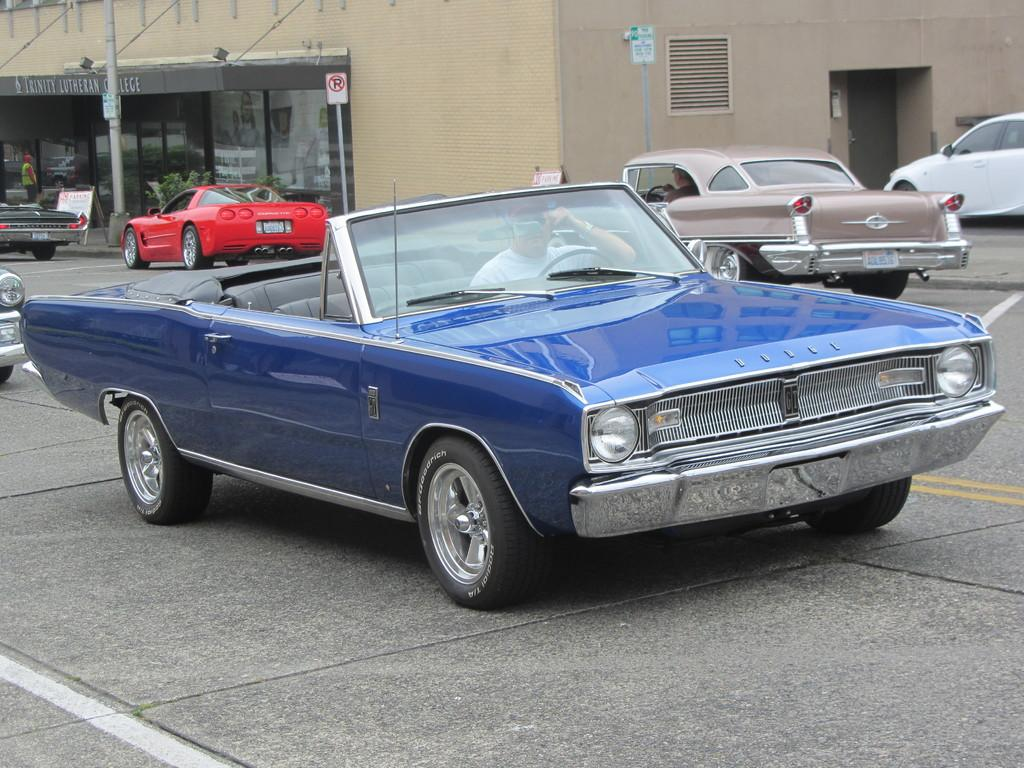What is the main subject of the image? The main subject of the image is many vehicles. What can be seen in the background of the image? There is a building in the background of the image. What type of objects are present with the sign boards? The sign boards have poles in the image. Can you identify any people in the image? Yes, there is a person visible in the image. What is the title of the argument between the vehicles in the image? There is no argument between the vehicles in the image, and therefore no title can be assigned. 